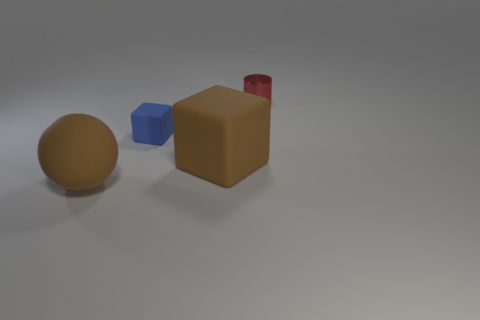Add 1 tiny blue matte cubes. How many objects exist? 5 Subtract all cylinders. How many objects are left? 3 Add 1 big brown rubber balls. How many big brown rubber balls exist? 2 Subtract 0 purple cylinders. How many objects are left? 4 Subtract all cyan cylinders. Subtract all green spheres. How many cylinders are left? 1 Subtract all small cyan metal blocks. Subtract all blue matte blocks. How many objects are left? 3 Add 1 brown rubber balls. How many brown rubber balls are left? 2 